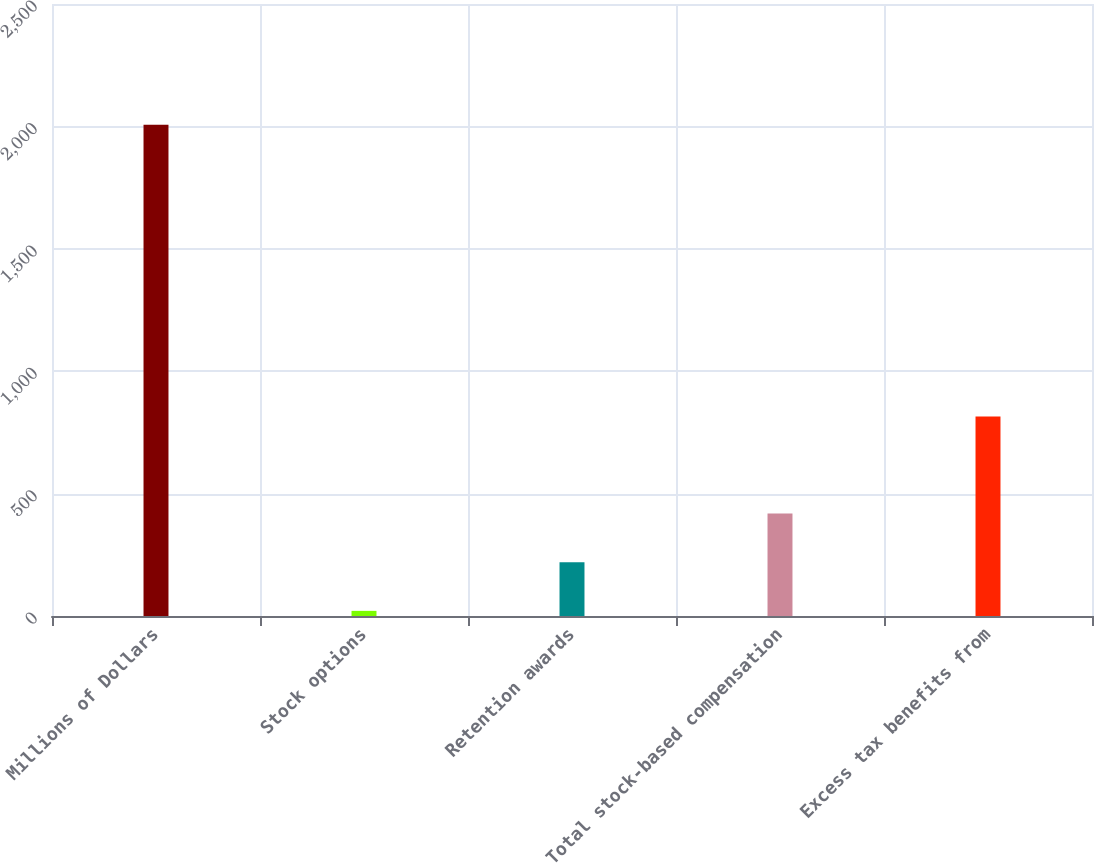<chart> <loc_0><loc_0><loc_500><loc_500><bar_chart><fcel>Millions of Dollars<fcel>Stock options<fcel>Retention awards<fcel>Total stock-based compensation<fcel>Excess tax benefits from<nl><fcel>2007<fcel>21<fcel>219.6<fcel>418.2<fcel>815.4<nl></chart> 